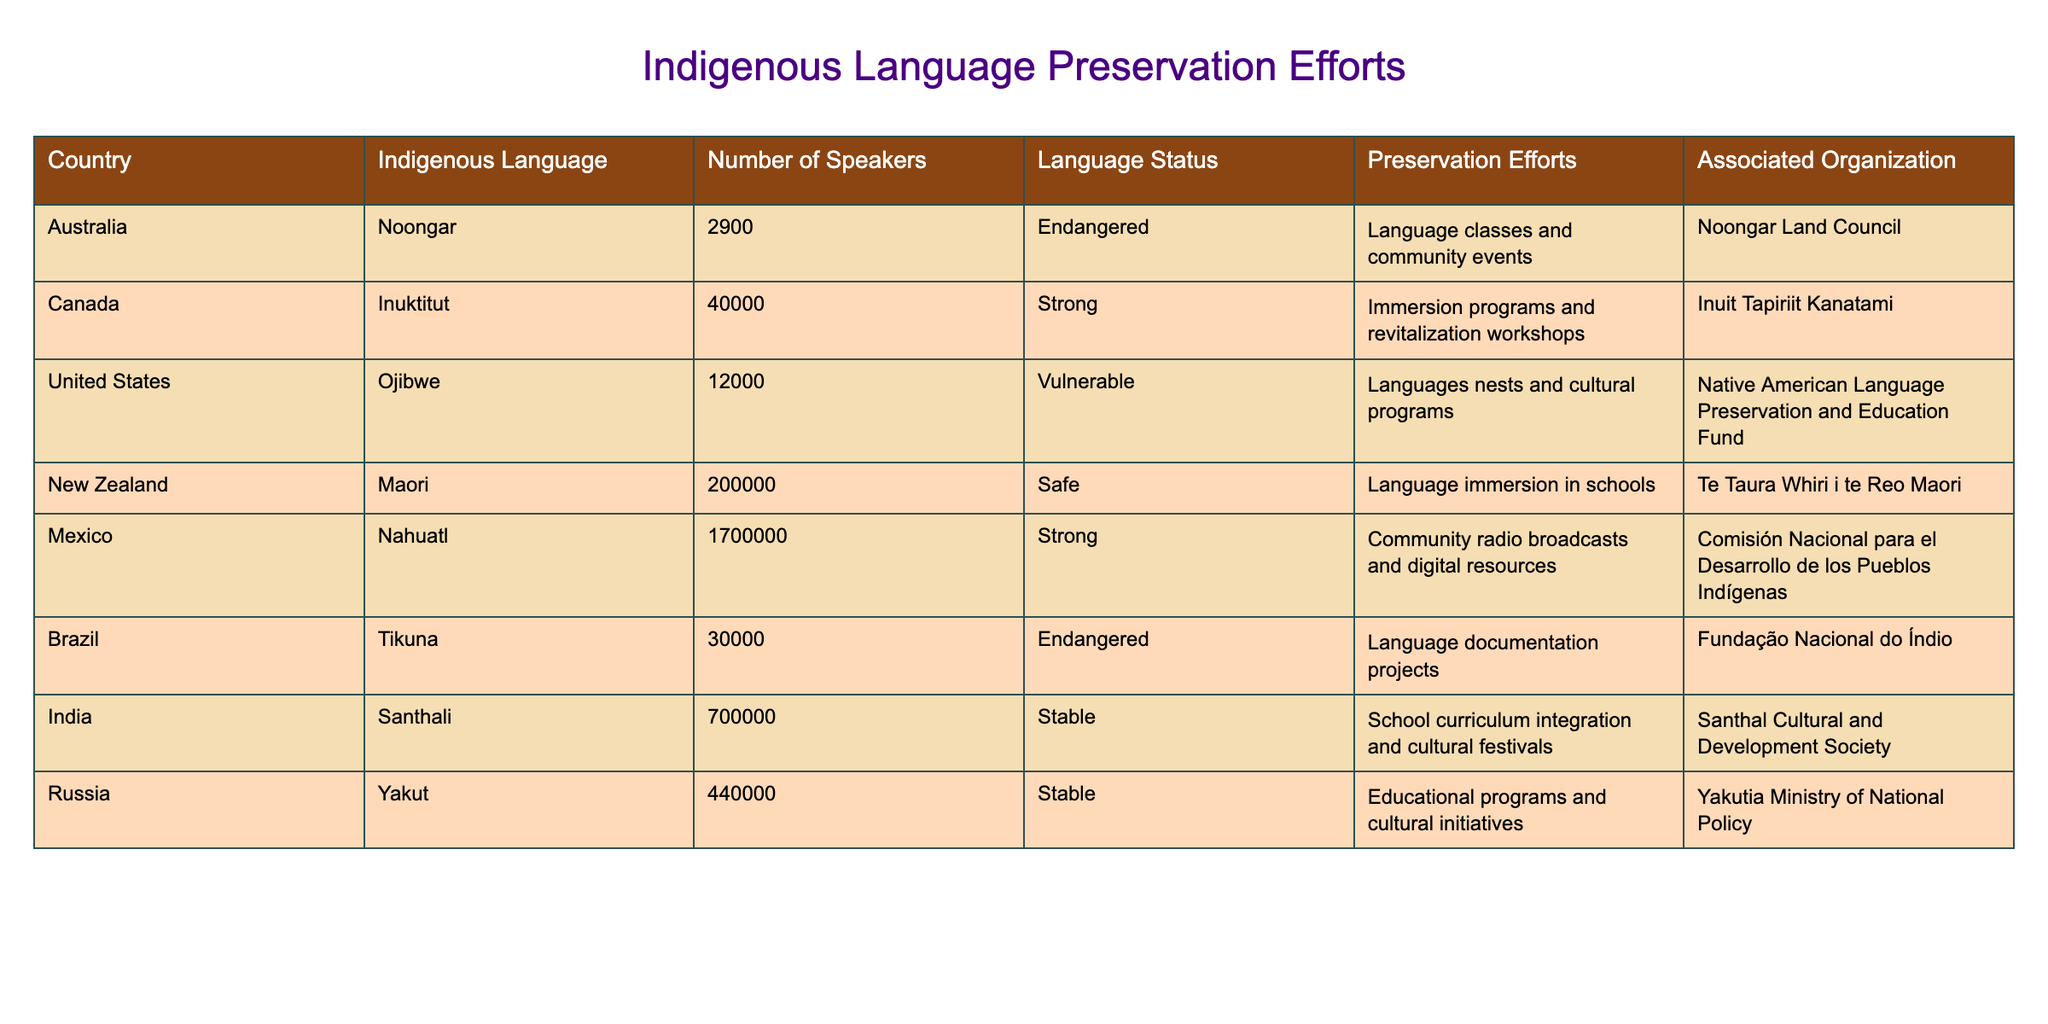What is the number of speakers of Nahuatl? The table lists Nahuatl under Mexico, with the corresponding value in the "Number of Speakers" column being 1,700,000.
Answer: 1,700,000 Which country has the most endangered language based on this table? The table shows that both Noongar and Tikuna are classified as endangered languages; however, Noongar has 2,900 speakers, while Tikuna has 30,000 speakers. Thus, Noongar has the lowest number of speakers among endangered languages.
Answer: Australia What types of preservation efforts are employed for the Ojibwe language? According to the table, the preservation efforts for the Ojibwe language include language nests and cultural programs.
Answer: Language nests and cultural programs Is the Santhali language considered stable? The table indicates that the Santhali language has a status of stable listed in the "Language Status" column. Thus, the answer is yes.
Answer: Yes How many countries in the table use immersion programs as a preservation effort? The table lists Canada (Inuktitut) and New Zealand (Maori) as having immersion programs. Counting these entries shows that there are two countries using this preservation effort.
Answer: 2 What is the average number of speakers for the languages listed in the table? To find the average, we sum the number of speakers: 2,900 (Noongar) + 40,000 (Inuktitut) + 12,000 (Ojibwe) + 200,000 (Maori) + 1,700,000 (Nahuatl) + 30,000 (Tikuna) + 700,000 (Santhali) + 440,000 (Yakut) = 2,924,900. There are 8 languages, so the average is 2,924,900 / 8 = 365,612.5.
Answer: 365,612.5 Are all languages in the table associated with organizations? By reviewing the 'Associated Organization' column, all languages listed have corresponding organizations mentioned. Thus, the answer is yes.
Answer: Yes Which language has the highest number of speakers among those considered safe? The Maori language in New Zealand, which has 200,000 speakers, is identified in the table as safe and has the highest number of speakers among languages with that designation.
Answer: Maori What preservation efforts are associated with the Santhali language? The table specifies that the preservation efforts for the Santhali language include school curriculum integration and cultural festivals.
Answer: School curriculum integration and cultural festivals 